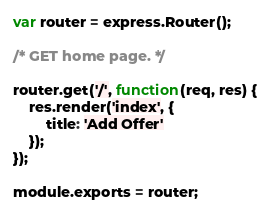Convert code to text. <code><loc_0><loc_0><loc_500><loc_500><_JavaScript_>var router = express.Router();

/* GET home page. */

router.get('/', function(req, res) {
    res.render('index', {
        title: 'Add Offer'
    });
});

module.exports = router;</code> 